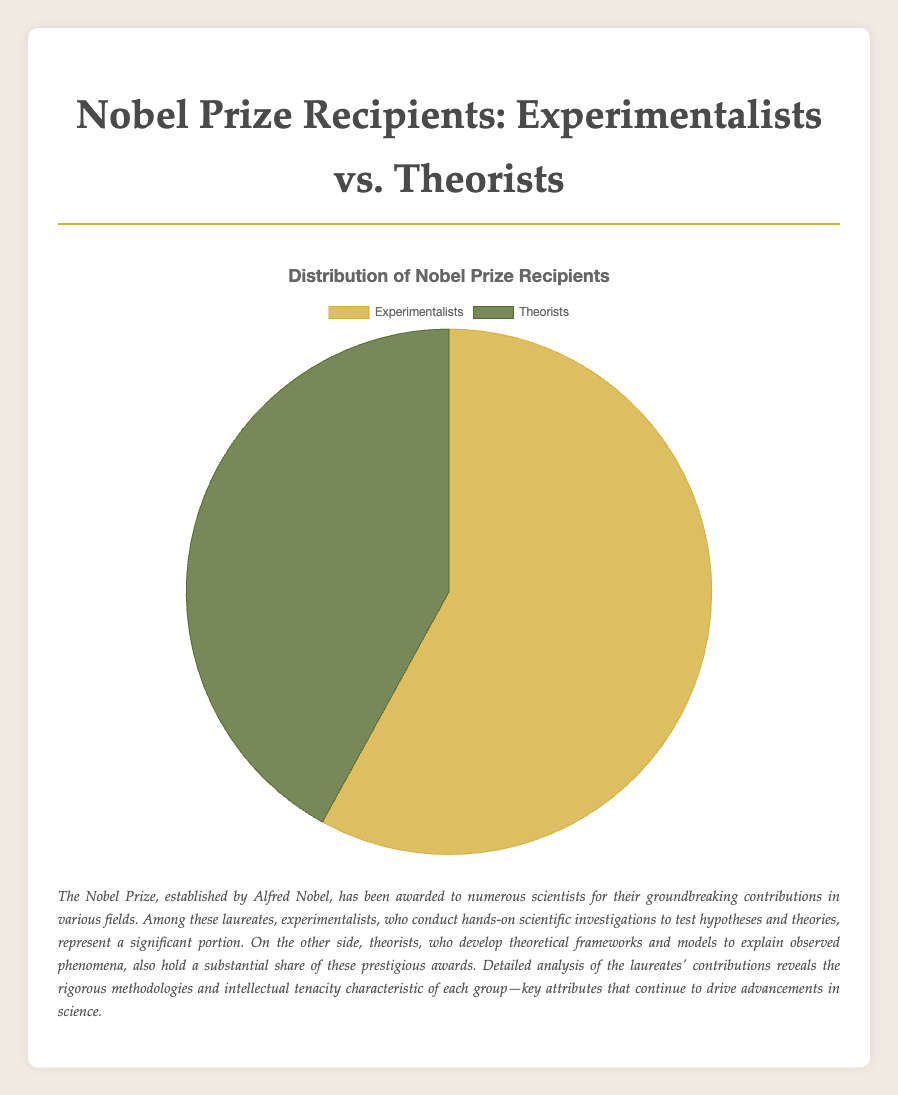What is the percentage of Nobel Prize recipients who are experimentalists? The pie chart shows a segment labeled "Experimentalists" corresponding to 58%. Thus, the percentage of Nobel Prize recipients who are experimentalists is 58%.
Answer: 58% What is the percentage difference between experimentalists and theorists among Nobel Prize recipients? The pie chart indicates that 58% are experimentalists and 42% are theorists. The difference can be calculated as 58% - 42% = 16%.
Answer: 16% Which category has a higher proportion of Nobel Prize recipients, experimentalists or theorists? By referring to the pie chart, we see that the experimentalists segment is larger, indicating that experimentalists have a higher proportion (58%) compared to theorists (42%).
Answer: Experimentalists What is the ratio of experimentalists to theorists among Nobel Prize recipients? The percentage of experimentalists is 58 and theorists is 42. The ratio can be calculated as 58:42, which simplifies to 29:21 when divided by 2.
Answer: 29:21 What color represents the theorists in the pie chart? Observing the pie chart, the segment for theorists is indicated in a color different from that of experimentalists. In this chart, theorists are represented by the green segment.
Answer: Green If you combine the percentages of both categories, what is the total? The total percentage from combining experimentalists (58%) and theorists (42%) is 58% + 42% = 100%.
Answer: 100% What would be the average percentage if experimentalists and theorists were combined into one category? The combined total percentage is 100% for experimentalists and theorists together. Since there are two categories, the average would be 100% / 2 = 50%.
Answer: 50% By how much do experimentalists exceed theorists in percentage points? To find out how much more experimentalists exceed theorists, subtract the percentage of theorists from experimentalists: 58% - 42% = 16%.
Answer: 16% 